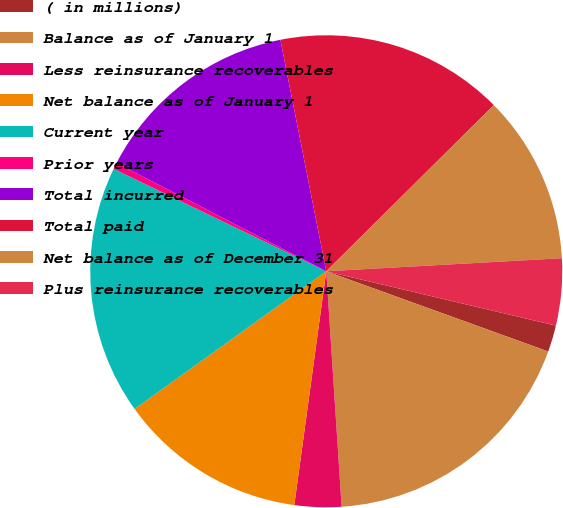<chart> <loc_0><loc_0><loc_500><loc_500><pie_chart><fcel>( in millions)<fcel>Balance as of January 1<fcel>Less reinsurance recoverables<fcel>Net balance as of January 1<fcel>Current year<fcel>Prior years<fcel>Total incurred<fcel>Total paid<fcel>Net balance as of December 31<fcel>Plus reinsurance recoverables<nl><fcel>1.82%<fcel>18.44%<fcel>3.2%<fcel>12.92%<fcel>17.06%<fcel>0.44%<fcel>14.3%<fcel>15.68%<fcel>11.55%<fcel>4.58%<nl></chart> 